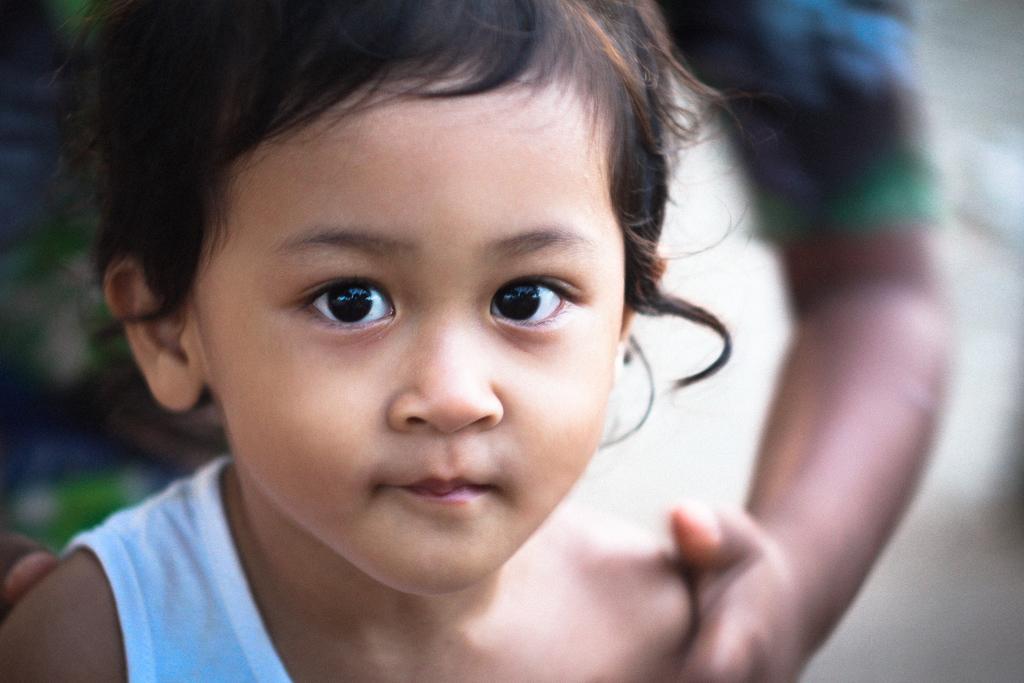Could you give a brief overview of what you see in this image? In this image there is a child, there is a person's hand, the background of the image is white in color. 